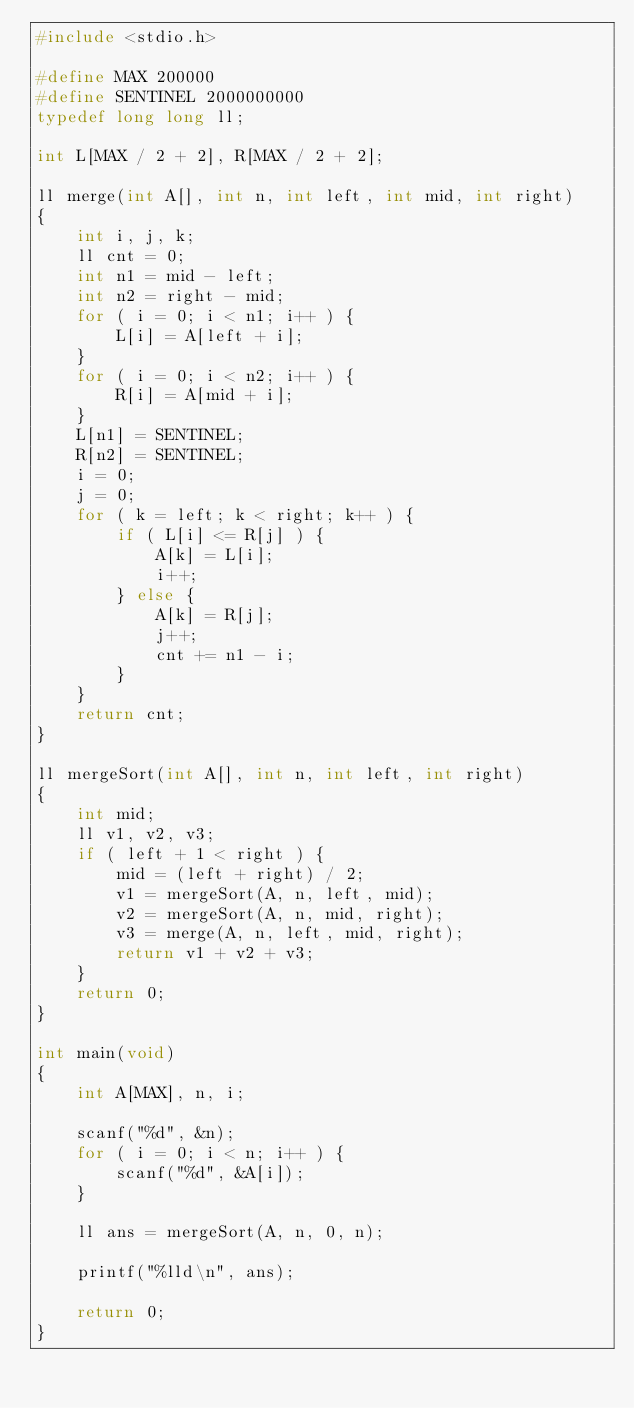Convert code to text. <code><loc_0><loc_0><loc_500><loc_500><_C_>#include <stdio.h>

#define MAX 200000
#define SENTINEL 2000000000
typedef long long ll;

int L[MAX / 2 + 2], R[MAX / 2 + 2];

ll merge(int A[], int n, int left, int mid, int right)
{
    int i, j, k;
    ll cnt = 0;
    int n1 = mid - left;
    int n2 = right - mid;
    for ( i = 0; i < n1; i++ ) {
        L[i] = A[left + i];
    }
    for ( i = 0; i < n2; i++ ) {
        R[i] = A[mid + i];
    }
    L[n1] = SENTINEL;
    R[n2] = SENTINEL;
    i = 0;
    j = 0;
    for ( k = left; k < right; k++ ) {
        if ( L[i] <= R[j] ) {
            A[k] = L[i];
            i++;
        } else {
            A[k] = R[j];
            j++;
            cnt += n1 - i;
        }
    }
    return cnt;
}

ll mergeSort(int A[], int n, int left, int right)
{
    int mid;
    ll v1, v2, v3;
    if ( left + 1 < right ) {
        mid = (left + right) / 2;
        v1 = mergeSort(A, n, left, mid);
        v2 = mergeSort(A, n, mid, right);
        v3 = merge(A, n, left, mid, right);
        return v1 + v2 + v3;
    }
    return 0;
}

int main(void)
{
    int A[MAX], n, i;

    scanf("%d", &n);
    for ( i = 0; i < n; i++ ) {
        scanf("%d", &A[i]);
    }

    ll ans = mergeSort(A, n, 0, n);

    printf("%lld\n", ans);

    return 0;
}
</code> 